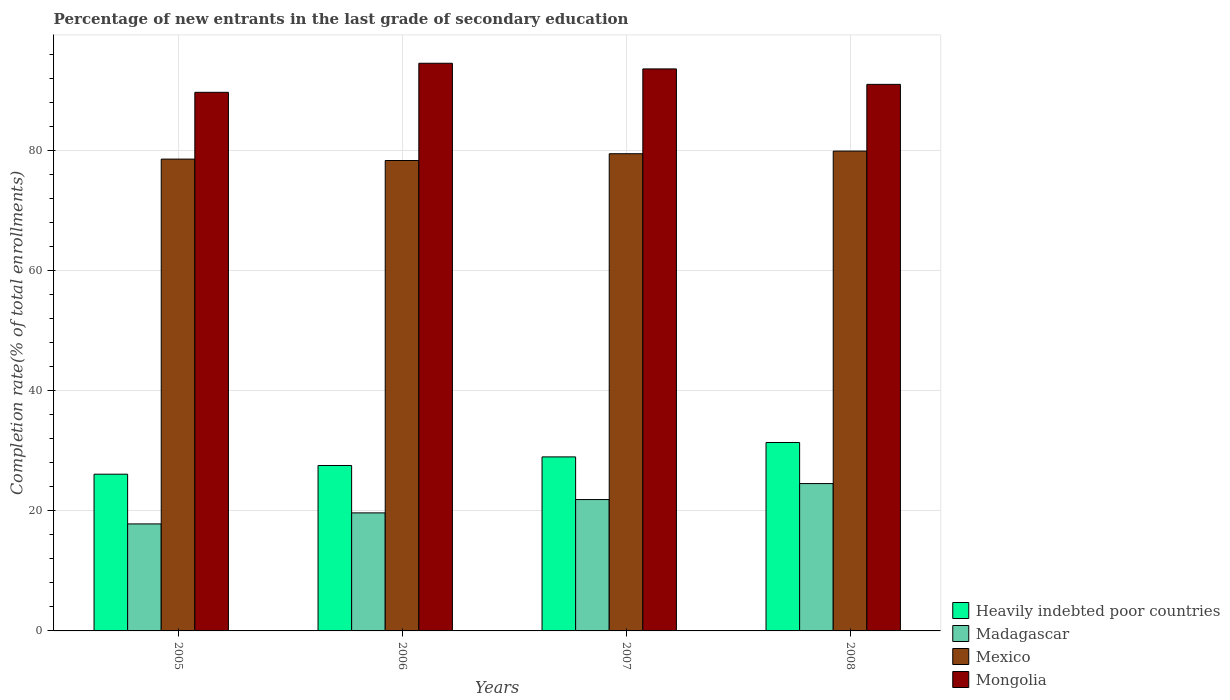How many different coloured bars are there?
Offer a very short reply. 4. How many groups of bars are there?
Your response must be concise. 4. Are the number of bars per tick equal to the number of legend labels?
Your answer should be compact. Yes. How many bars are there on the 3rd tick from the left?
Your response must be concise. 4. How many bars are there on the 4th tick from the right?
Your answer should be very brief. 4. What is the label of the 2nd group of bars from the left?
Provide a succinct answer. 2006. What is the percentage of new entrants in Mongolia in 2005?
Keep it short and to the point. 89.76. Across all years, what is the maximum percentage of new entrants in Mexico?
Offer a very short reply. 79.97. Across all years, what is the minimum percentage of new entrants in Madagascar?
Keep it short and to the point. 17.83. In which year was the percentage of new entrants in Madagascar maximum?
Provide a short and direct response. 2008. In which year was the percentage of new entrants in Madagascar minimum?
Your answer should be very brief. 2005. What is the total percentage of new entrants in Mexico in the graph?
Your answer should be very brief. 316.53. What is the difference between the percentage of new entrants in Mongolia in 2005 and that in 2006?
Make the answer very short. -4.84. What is the difference between the percentage of new entrants in Heavily indebted poor countries in 2008 and the percentage of new entrants in Mexico in 2005?
Your answer should be compact. -47.23. What is the average percentage of new entrants in Mongolia per year?
Your response must be concise. 92.28. In the year 2008, what is the difference between the percentage of new entrants in Heavily indebted poor countries and percentage of new entrants in Mexico?
Your answer should be compact. -48.57. What is the ratio of the percentage of new entrants in Heavily indebted poor countries in 2007 to that in 2008?
Offer a terse response. 0.92. Is the difference between the percentage of new entrants in Heavily indebted poor countries in 2007 and 2008 greater than the difference between the percentage of new entrants in Mexico in 2007 and 2008?
Keep it short and to the point. No. What is the difference between the highest and the second highest percentage of new entrants in Mongolia?
Make the answer very short. 0.94. What is the difference between the highest and the lowest percentage of new entrants in Mongolia?
Keep it short and to the point. 4.84. In how many years, is the percentage of new entrants in Mongolia greater than the average percentage of new entrants in Mongolia taken over all years?
Make the answer very short. 2. Is the sum of the percentage of new entrants in Mexico in 2006 and 2008 greater than the maximum percentage of new entrants in Heavily indebted poor countries across all years?
Your response must be concise. Yes. What does the 1st bar from the left in 2006 represents?
Provide a short and direct response. Heavily indebted poor countries. What does the 2nd bar from the right in 2005 represents?
Your answer should be very brief. Mexico. How many bars are there?
Ensure brevity in your answer.  16. What is the difference between two consecutive major ticks on the Y-axis?
Offer a very short reply. 20. Are the values on the major ticks of Y-axis written in scientific E-notation?
Ensure brevity in your answer.  No. Does the graph contain any zero values?
Your answer should be compact. No. Does the graph contain grids?
Give a very brief answer. Yes. How many legend labels are there?
Your response must be concise. 4. What is the title of the graph?
Provide a succinct answer. Percentage of new entrants in the last grade of secondary education. Does "Albania" appear as one of the legend labels in the graph?
Your response must be concise. No. What is the label or title of the Y-axis?
Your response must be concise. Completion rate(% of total enrollments). What is the Completion rate(% of total enrollments) of Heavily indebted poor countries in 2005?
Your response must be concise. 26.12. What is the Completion rate(% of total enrollments) in Madagascar in 2005?
Your answer should be compact. 17.83. What is the Completion rate(% of total enrollments) of Mexico in 2005?
Your answer should be very brief. 78.63. What is the Completion rate(% of total enrollments) in Mongolia in 2005?
Make the answer very short. 89.76. What is the Completion rate(% of total enrollments) of Heavily indebted poor countries in 2006?
Provide a succinct answer. 27.57. What is the Completion rate(% of total enrollments) in Madagascar in 2006?
Make the answer very short. 19.67. What is the Completion rate(% of total enrollments) in Mexico in 2006?
Give a very brief answer. 78.4. What is the Completion rate(% of total enrollments) of Mongolia in 2006?
Give a very brief answer. 94.61. What is the Completion rate(% of total enrollments) in Heavily indebted poor countries in 2007?
Your answer should be very brief. 29. What is the Completion rate(% of total enrollments) in Madagascar in 2007?
Your response must be concise. 21.89. What is the Completion rate(% of total enrollments) in Mexico in 2007?
Provide a succinct answer. 79.53. What is the Completion rate(% of total enrollments) in Mongolia in 2007?
Your response must be concise. 93.66. What is the Completion rate(% of total enrollments) of Heavily indebted poor countries in 2008?
Give a very brief answer. 31.4. What is the Completion rate(% of total enrollments) in Madagascar in 2008?
Your answer should be compact. 24.56. What is the Completion rate(% of total enrollments) in Mexico in 2008?
Make the answer very short. 79.97. What is the Completion rate(% of total enrollments) in Mongolia in 2008?
Your response must be concise. 91.09. Across all years, what is the maximum Completion rate(% of total enrollments) in Heavily indebted poor countries?
Keep it short and to the point. 31.4. Across all years, what is the maximum Completion rate(% of total enrollments) of Madagascar?
Offer a terse response. 24.56. Across all years, what is the maximum Completion rate(% of total enrollments) of Mexico?
Give a very brief answer. 79.97. Across all years, what is the maximum Completion rate(% of total enrollments) of Mongolia?
Provide a short and direct response. 94.61. Across all years, what is the minimum Completion rate(% of total enrollments) in Heavily indebted poor countries?
Offer a very short reply. 26.12. Across all years, what is the minimum Completion rate(% of total enrollments) in Madagascar?
Offer a very short reply. 17.83. Across all years, what is the minimum Completion rate(% of total enrollments) of Mexico?
Provide a short and direct response. 78.4. Across all years, what is the minimum Completion rate(% of total enrollments) in Mongolia?
Ensure brevity in your answer.  89.76. What is the total Completion rate(% of total enrollments) of Heavily indebted poor countries in the graph?
Provide a succinct answer. 114.1. What is the total Completion rate(% of total enrollments) in Madagascar in the graph?
Your answer should be compact. 83.96. What is the total Completion rate(% of total enrollments) of Mexico in the graph?
Your answer should be very brief. 316.53. What is the total Completion rate(% of total enrollments) in Mongolia in the graph?
Your response must be concise. 369.13. What is the difference between the Completion rate(% of total enrollments) of Heavily indebted poor countries in 2005 and that in 2006?
Offer a very short reply. -1.45. What is the difference between the Completion rate(% of total enrollments) in Madagascar in 2005 and that in 2006?
Keep it short and to the point. -1.84. What is the difference between the Completion rate(% of total enrollments) of Mexico in 2005 and that in 2006?
Provide a succinct answer. 0.23. What is the difference between the Completion rate(% of total enrollments) in Mongolia in 2005 and that in 2006?
Your response must be concise. -4.84. What is the difference between the Completion rate(% of total enrollments) in Heavily indebted poor countries in 2005 and that in 2007?
Provide a short and direct response. -2.88. What is the difference between the Completion rate(% of total enrollments) of Madagascar in 2005 and that in 2007?
Your answer should be compact. -4.06. What is the difference between the Completion rate(% of total enrollments) in Mexico in 2005 and that in 2007?
Your answer should be very brief. -0.9. What is the difference between the Completion rate(% of total enrollments) of Mongolia in 2005 and that in 2007?
Provide a short and direct response. -3.9. What is the difference between the Completion rate(% of total enrollments) of Heavily indebted poor countries in 2005 and that in 2008?
Offer a terse response. -5.29. What is the difference between the Completion rate(% of total enrollments) in Madagascar in 2005 and that in 2008?
Provide a succinct answer. -6.72. What is the difference between the Completion rate(% of total enrollments) of Mexico in 2005 and that in 2008?
Provide a succinct answer. -1.34. What is the difference between the Completion rate(% of total enrollments) of Mongolia in 2005 and that in 2008?
Keep it short and to the point. -1.33. What is the difference between the Completion rate(% of total enrollments) of Heavily indebted poor countries in 2006 and that in 2007?
Offer a very short reply. -1.43. What is the difference between the Completion rate(% of total enrollments) in Madagascar in 2006 and that in 2007?
Ensure brevity in your answer.  -2.22. What is the difference between the Completion rate(% of total enrollments) in Mexico in 2006 and that in 2007?
Your answer should be compact. -1.13. What is the difference between the Completion rate(% of total enrollments) in Mongolia in 2006 and that in 2007?
Make the answer very short. 0.94. What is the difference between the Completion rate(% of total enrollments) in Heavily indebted poor countries in 2006 and that in 2008?
Your response must be concise. -3.83. What is the difference between the Completion rate(% of total enrollments) in Madagascar in 2006 and that in 2008?
Offer a very short reply. -4.88. What is the difference between the Completion rate(% of total enrollments) of Mexico in 2006 and that in 2008?
Ensure brevity in your answer.  -1.57. What is the difference between the Completion rate(% of total enrollments) in Mongolia in 2006 and that in 2008?
Your response must be concise. 3.52. What is the difference between the Completion rate(% of total enrollments) of Heavily indebted poor countries in 2007 and that in 2008?
Your response must be concise. -2.4. What is the difference between the Completion rate(% of total enrollments) in Madagascar in 2007 and that in 2008?
Ensure brevity in your answer.  -2.66. What is the difference between the Completion rate(% of total enrollments) in Mexico in 2007 and that in 2008?
Offer a very short reply. -0.44. What is the difference between the Completion rate(% of total enrollments) in Mongolia in 2007 and that in 2008?
Provide a succinct answer. 2.57. What is the difference between the Completion rate(% of total enrollments) in Heavily indebted poor countries in 2005 and the Completion rate(% of total enrollments) in Madagascar in 2006?
Your response must be concise. 6.45. What is the difference between the Completion rate(% of total enrollments) in Heavily indebted poor countries in 2005 and the Completion rate(% of total enrollments) in Mexico in 2006?
Offer a very short reply. -52.28. What is the difference between the Completion rate(% of total enrollments) in Heavily indebted poor countries in 2005 and the Completion rate(% of total enrollments) in Mongolia in 2006?
Give a very brief answer. -68.49. What is the difference between the Completion rate(% of total enrollments) in Madagascar in 2005 and the Completion rate(% of total enrollments) in Mexico in 2006?
Keep it short and to the point. -60.57. What is the difference between the Completion rate(% of total enrollments) of Madagascar in 2005 and the Completion rate(% of total enrollments) of Mongolia in 2006?
Offer a very short reply. -76.77. What is the difference between the Completion rate(% of total enrollments) of Mexico in 2005 and the Completion rate(% of total enrollments) of Mongolia in 2006?
Give a very brief answer. -15.97. What is the difference between the Completion rate(% of total enrollments) of Heavily indebted poor countries in 2005 and the Completion rate(% of total enrollments) of Madagascar in 2007?
Keep it short and to the point. 4.22. What is the difference between the Completion rate(% of total enrollments) in Heavily indebted poor countries in 2005 and the Completion rate(% of total enrollments) in Mexico in 2007?
Your response must be concise. -53.41. What is the difference between the Completion rate(% of total enrollments) of Heavily indebted poor countries in 2005 and the Completion rate(% of total enrollments) of Mongolia in 2007?
Keep it short and to the point. -67.54. What is the difference between the Completion rate(% of total enrollments) in Madagascar in 2005 and the Completion rate(% of total enrollments) in Mexico in 2007?
Provide a short and direct response. -61.7. What is the difference between the Completion rate(% of total enrollments) in Madagascar in 2005 and the Completion rate(% of total enrollments) in Mongolia in 2007?
Offer a very short reply. -75.83. What is the difference between the Completion rate(% of total enrollments) in Mexico in 2005 and the Completion rate(% of total enrollments) in Mongolia in 2007?
Ensure brevity in your answer.  -15.03. What is the difference between the Completion rate(% of total enrollments) of Heavily indebted poor countries in 2005 and the Completion rate(% of total enrollments) of Madagascar in 2008?
Give a very brief answer. 1.56. What is the difference between the Completion rate(% of total enrollments) in Heavily indebted poor countries in 2005 and the Completion rate(% of total enrollments) in Mexico in 2008?
Offer a very short reply. -53.85. What is the difference between the Completion rate(% of total enrollments) in Heavily indebted poor countries in 2005 and the Completion rate(% of total enrollments) in Mongolia in 2008?
Offer a terse response. -64.97. What is the difference between the Completion rate(% of total enrollments) of Madagascar in 2005 and the Completion rate(% of total enrollments) of Mexico in 2008?
Keep it short and to the point. -62.14. What is the difference between the Completion rate(% of total enrollments) of Madagascar in 2005 and the Completion rate(% of total enrollments) of Mongolia in 2008?
Your answer should be compact. -73.26. What is the difference between the Completion rate(% of total enrollments) in Mexico in 2005 and the Completion rate(% of total enrollments) in Mongolia in 2008?
Your response must be concise. -12.46. What is the difference between the Completion rate(% of total enrollments) of Heavily indebted poor countries in 2006 and the Completion rate(% of total enrollments) of Madagascar in 2007?
Ensure brevity in your answer.  5.68. What is the difference between the Completion rate(% of total enrollments) of Heavily indebted poor countries in 2006 and the Completion rate(% of total enrollments) of Mexico in 2007?
Provide a short and direct response. -51.96. What is the difference between the Completion rate(% of total enrollments) in Heavily indebted poor countries in 2006 and the Completion rate(% of total enrollments) in Mongolia in 2007?
Your answer should be very brief. -66.09. What is the difference between the Completion rate(% of total enrollments) in Madagascar in 2006 and the Completion rate(% of total enrollments) in Mexico in 2007?
Ensure brevity in your answer.  -59.86. What is the difference between the Completion rate(% of total enrollments) in Madagascar in 2006 and the Completion rate(% of total enrollments) in Mongolia in 2007?
Provide a short and direct response. -73.99. What is the difference between the Completion rate(% of total enrollments) in Mexico in 2006 and the Completion rate(% of total enrollments) in Mongolia in 2007?
Your answer should be compact. -15.26. What is the difference between the Completion rate(% of total enrollments) of Heavily indebted poor countries in 2006 and the Completion rate(% of total enrollments) of Madagascar in 2008?
Your answer should be very brief. 3.01. What is the difference between the Completion rate(% of total enrollments) in Heavily indebted poor countries in 2006 and the Completion rate(% of total enrollments) in Mexico in 2008?
Provide a short and direct response. -52.4. What is the difference between the Completion rate(% of total enrollments) of Heavily indebted poor countries in 2006 and the Completion rate(% of total enrollments) of Mongolia in 2008?
Provide a short and direct response. -63.52. What is the difference between the Completion rate(% of total enrollments) of Madagascar in 2006 and the Completion rate(% of total enrollments) of Mexico in 2008?
Provide a short and direct response. -60.3. What is the difference between the Completion rate(% of total enrollments) of Madagascar in 2006 and the Completion rate(% of total enrollments) of Mongolia in 2008?
Your response must be concise. -71.42. What is the difference between the Completion rate(% of total enrollments) of Mexico in 2006 and the Completion rate(% of total enrollments) of Mongolia in 2008?
Provide a succinct answer. -12.69. What is the difference between the Completion rate(% of total enrollments) of Heavily indebted poor countries in 2007 and the Completion rate(% of total enrollments) of Madagascar in 2008?
Make the answer very short. 4.45. What is the difference between the Completion rate(% of total enrollments) in Heavily indebted poor countries in 2007 and the Completion rate(% of total enrollments) in Mexico in 2008?
Your answer should be compact. -50.97. What is the difference between the Completion rate(% of total enrollments) of Heavily indebted poor countries in 2007 and the Completion rate(% of total enrollments) of Mongolia in 2008?
Offer a terse response. -62.09. What is the difference between the Completion rate(% of total enrollments) of Madagascar in 2007 and the Completion rate(% of total enrollments) of Mexico in 2008?
Give a very brief answer. -58.08. What is the difference between the Completion rate(% of total enrollments) of Madagascar in 2007 and the Completion rate(% of total enrollments) of Mongolia in 2008?
Your response must be concise. -69.2. What is the difference between the Completion rate(% of total enrollments) of Mexico in 2007 and the Completion rate(% of total enrollments) of Mongolia in 2008?
Provide a succinct answer. -11.56. What is the average Completion rate(% of total enrollments) of Heavily indebted poor countries per year?
Your answer should be compact. 28.52. What is the average Completion rate(% of total enrollments) in Madagascar per year?
Offer a terse response. 20.99. What is the average Completion rate(% of total enrollments) of Mexico per year?
Your answer should be very brief. 79.13. What is the average Completion rate(% of total enrollments) of Mongolia per year?
Your answer should be very brief. 92.28. In the year 2005, what is the difference between the Completion rate(% of total enrollments) of Heavily indebted poor countries and Completion rate(% of total enrollments) of Madagascar?
Ensure brevity in your answer.  8.29. In the year 2005, what is the difference between the Completion rate(% of total enrollments) of Heavily indebted poor countries and Completion rate(% of total enrollments) of Mexico?
Your response must be concise. -52.51. In the year 2005, what is the difference between the Completion rate(% of total enrollments) of Heavily indebted poor countries and Completion rate(% of total enrollments) of Mongolia?
Ensure brevity in your answer.  -63.65. In the year 2005, what is the difference between the Completion rate(% of total enrollments) of Madagascar and Completion rate(% of total enrollments) of Mexico?
Your response must be concise. -60.8. In the year 2005, what is the difference between the Completion rate(% of total enrollments) in Madagascar and Completion rate(% of total enrollments) in Mongolia?
Give a very brief answer. -71.93. In the year 2005, what is the difference between the Completion rate(% of total enrollments) in Mexico and Completion rate(% of total enrollments) in Mongolia?
Your answer should be compact. -11.13. In the year 2006, what is the difference between the Completion rate(% of total enrollments) of Heavily indebted poor countries and Completion rate(% of total enrollments) of Madagascar?
Your response must be concise. 7.9. In the year 2006, what is the difference between the Completion rate(% of total enrollments) of Heavily indebted poor countries and Completion rate(% of total enrollments) of Mexico?
Offer a terse response. -50.83. In the year 2006, what is the difference between the Completion rate(% of total enrollments) in Heavily indebted poor countries and Completion rate(% of total enrollments) in Mongolia?
Your answer should be compact. -67.04. In the year 2006, what is the difference between the Completion rate(% of total enrollments) of Madagascar and Completion rate(% of total enrollments) of Mexico?
Your response must be concise. -58.73. In the year 2006, what is the difference between the Completion rate(% of total enrollments) of Madagascar and Completion rate(% of total enrollments) of Mongolia?
Your answer should be compact. -74.94. In the year 2006, what is the difference between the Completion rate(% of total enrollments) of Mexico and Completion rate(% of total enrollments) of Mongolia?
Offer a very short reply. -16.21. In the year 2007, what is the difference between the Completion rate(% of total enrollments) in Heavily indebted poor countries and Completion rate(% of total enrollments) in Madagascar?
Give a very brief answer. 7.11. In the year 2007, what is the difference between the Completion rate(% of total enrollments) in Heavily indebted poor countries and Completion rate(% of total enrollments) in Mexico?
Offer a very short reply. -50.53. In the year 2007, what is the difference between the Completion rate(% of total enrollments) of Heavily indebted poor countries and Completion rate(% of total enrollments) of Mongolia?
Provide a succinct answer. -64.66. In the year 2007, what is the difference between the Completion rate(% of total enrollments) of Madagascar and Completion rate(% of total enrollments) of Mexico?
Offer a very short reply. -57.63. In the year 2007, what is the difference between the Completion rate(% of total enrollments) in Madagascar and Completion rate(% of total enrollments) in Mongolia?
Provide a short and direct response. -71.77. In the year 2007, what is the difference between the Completion rate(% of total enrollments) of Mexico and Completion rate(% of total enrollments) of Mongolia?
Provide a short and direct response. -14.13. In the year 2008, what is the difference between the Completion rate(% of total enrollments) of Heavily indebted poor countries and Completion rate(% of total enrollments) of Madagascar?
Keep it short and to the point. 6.85. In the year 2008, what is the difference between the Completion rate(% of total enrollments) in Heavily indebted poor countries and Completion rate(% of total enrollments) in Mexico?
Your response must be concise. -48.57. In the year 2008, what is the difference between the Completion rate(% of total enrollments) of Heavily indebted poor countries and Completion rate(% of total enrollments) of Mongolia?
Keep it short and to the point. -59.69. In the year 2008, what is the difference between the Completion rate(% of total enrollments) in Madagascar and Completion rate(% of total enrollments) in Mexico?
Make the answer very short. -55.41. In the year 2008, what is the difference between the Completion rate(% of total enrollments) of Madagascar and Completion rate(% of total enrollments) of Mongolia?
Provide a short and direct response. -66.53. In the year 2008, what is the difference between the Completion rate(% of total enrollments) of Mexico and Completion rate(% of total enrollments) of Mongolia?
Make the answer very short. -11.12. What is the ratio of the Completion rate(% of total enrollments) in Heavily indebted poor countries in 2005 to that in 2006?
Give a very brief answer. 0.95. What is the ratio of the Completion rate(% of total enrollments) of Madagascar in 2005 to that in 2006?
Your response must be concise. 0.91. What is the ratio of the Completion rate(% of total enrollments) in Mexico in 2005 to that in 2006?
Offer a terse response. 1. What is the ratio of the Completion rate(% of total enrollments) of Mongolia in 2005 to that in 2006?
Make the answer very short. 0.95. What is the ratio of the Completion rate(% of total enrollments) of Heavily indebted poor countries in 2005 to that in 2007?
Keep it short and to the point. 0.9. What is the ratio of the Completion rate(% of total enrollments) of Madagascar in 2005 to that in 2007?
Your response must be concise. 0.81. What is the ratio of the Completion rate(% of total enrollments) in Mexico in 2005 to that in 2007?
Offer a terse response. 0.99. What is the ratio of the Completion rate(% of total enrollments) in Mongolia in 2005 to that in 2007?
Offer a terse response. 0.96. What is the ratio of the Completion rate(% of total enrollments) in Heavily indebted poor countries in 2005 to that in 2008?
Give a very brief answer. 0.83. What is the ratio of the Completion rate(% of total enrollments) in Madagascar in 2005 to that in 2008?
Your answer should be very brief. 0.73. What is the ratio of the Completion rate(% of total enrollments) of Mexico in 2005 to that in 2008?
Your answer should be very brief. 0.98. What is the ratio of the Completion rate(% of total enrollments) of Mongolia in 2005 to that in 2008?
Give a very brief answer. 0.99. What is the ratio of the Completion rate(% of total enrollments) of Heavily indebted poor countries in 2006 to that in 2007?
Offer a very short reply. 0.95. What is the ratio of the Completion rate(% of total enrollments) in Madagascar in 2006 to that in 2007?
Your answer should be compact. 0.9. What is the ratio of the Completion rate(% of total enrollments) in Mexico in 2006 to that in 2007?
Give a very brief answer. 0.99. What is the ratio of the Completion rate(% of total enrollments) of Heavily indebted poor countries in 2006 to that in 2008?
Keep it short and to the point. 0.88. What is the ratio of the Completion rate(% of total enrollments) of Madagascar in 2006 to that in 2008?
Your answer should be very brief. 0.8. What is the ratio of the Completion rate(% of total enrollments) in Mexico in 2006 to that in 2008?
Provide a succinct answer. 0.98. What is the ratio of the Completion rate(% of total enrollments) in Mongolia in 2006 to that in 2008?
Keep it short and to the point. 1.04. What is the ratio of the Completion rate(% of total enrollments) in Heavily indebted poor countries in 2007 to that in 2008?
Make the answer very short. 0.92. What is the ratio of the Completion rate(% of total enrollments) in Madagascar in 2007 to that in 2008?
Provide a short and direct response. 0.89. What is the ratio of the Completion rate(% of total enrollments) of Mexico in 2007 to that in 2008?
Make the answer very short. 0.99. What is the ratio of the Completion rate(% of total enrollments) of Mongolia in 2007 to that in 2008?
Ensure brevity in your answer.  1.03. What is the difference between the highest and the second highest Completion rate(% of total enrollments) in Heavily indebted poor countries?
Your response must be concise. 2.4. What is the difference between the highest and the second highest Completion rate(% of total enrollments) in Madagascar?
Offer a terse response. 2.66. What is the difference between the highest and the second highest Completion rate(% of total enrollments) of Mexico?
Provide a short and direct response. 0.44. What is the difference between the highest and the second highest Completion rate(% of total enrollments) in Mongolia?
Your answer should be very brief. 0.94. What is the difference between the highest and the lowest Completion rate(% of total enrollments) in Heavily indebted poor countries?
Keep it short and to the point. 5.29. What is the difference between the highest and the lowest Completion rate(% of total enrollments) of Madagascar?
Ensure brevity in your answer.  6.72. What is the difference between the highest and the lowest Completion rate(% of total enrollments) in Mexico?
Offer a very short reply. 1.57. What is the difference between the highest and the lowest Completion rate(% of total enrollments) of Mongolia?
Ensure brevity in your answer.  4.84. 